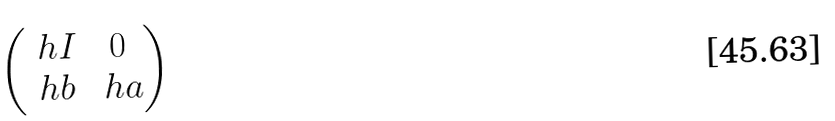<formula> <loc_0><loc_0><loc_500><loc_500>\begin{pmatrix} \ h I & 0 \\ \ h b & \ h a \end{pmatrix}</formula> 